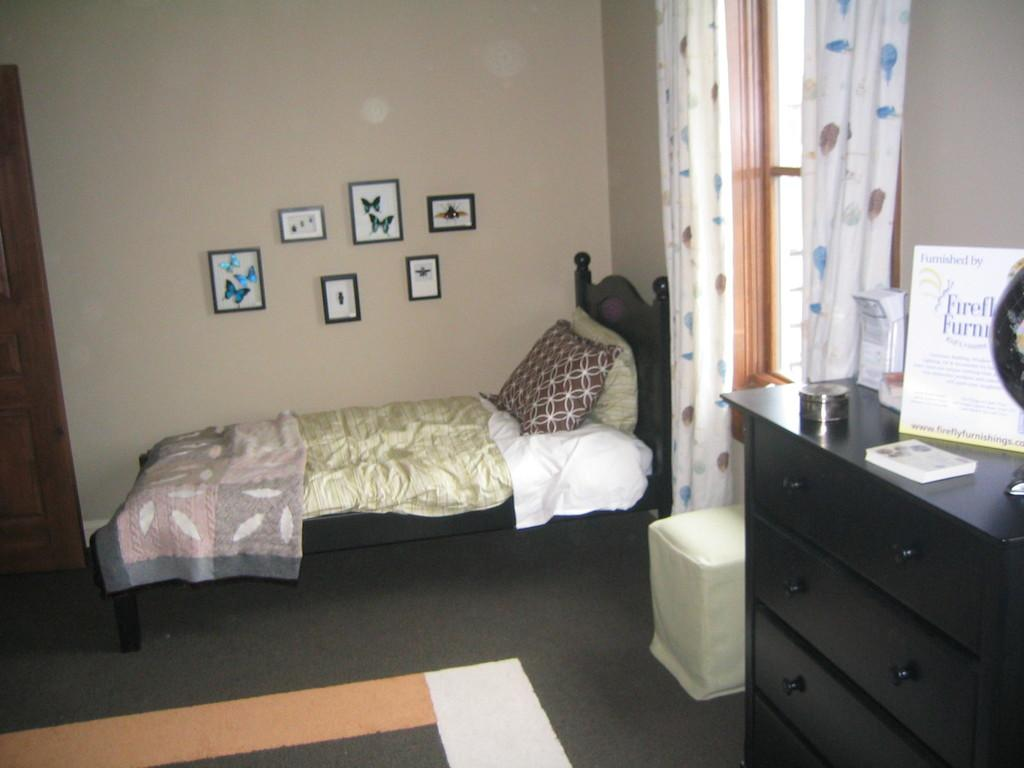What is covering the bed in the image? There is cloth on the bed. What can be seen on the drawers in the image? There is a box and a small book on the drawers. What is present near the window in the image? There is a window with curtains in the image. What type of furniture is visible in the image? There are drawers in the image. What is visible in the background of the image? There is a wall in the background of the image. Can you see a woman playing an instrument in the image? There is no woman playing an instrument in the image. Is there a net visible in the image? There is no net present in the image. 